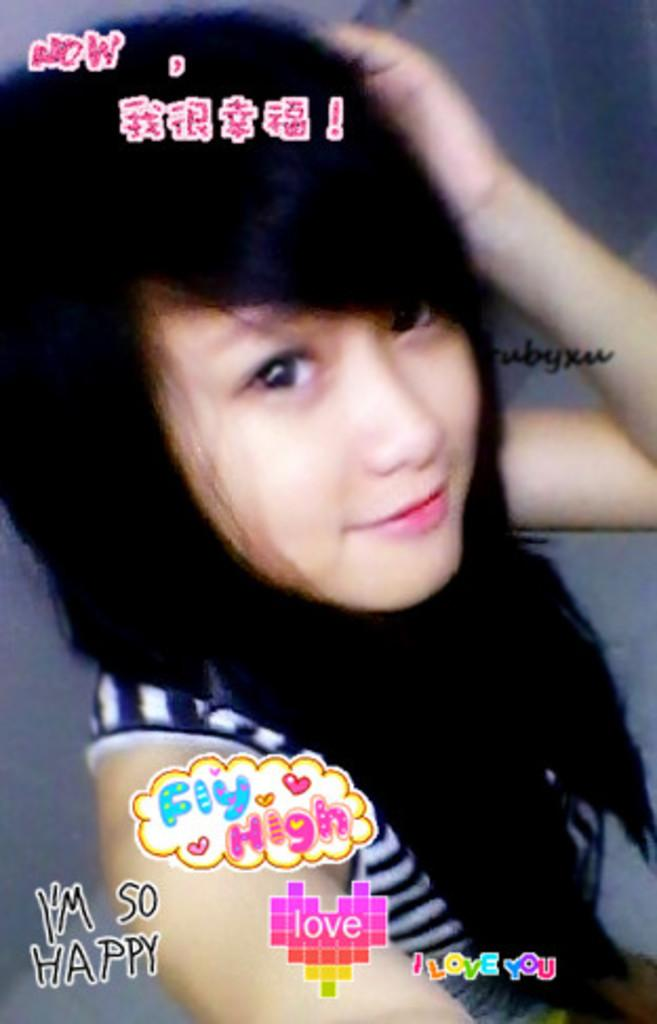What is the main subject of the image? There is a woman in the image. Can you describe any additional features or elements in the image? There is text written on the image. What type of degree is the woman holding in the image? There is no degree present in the image; it only features a woman and text. 